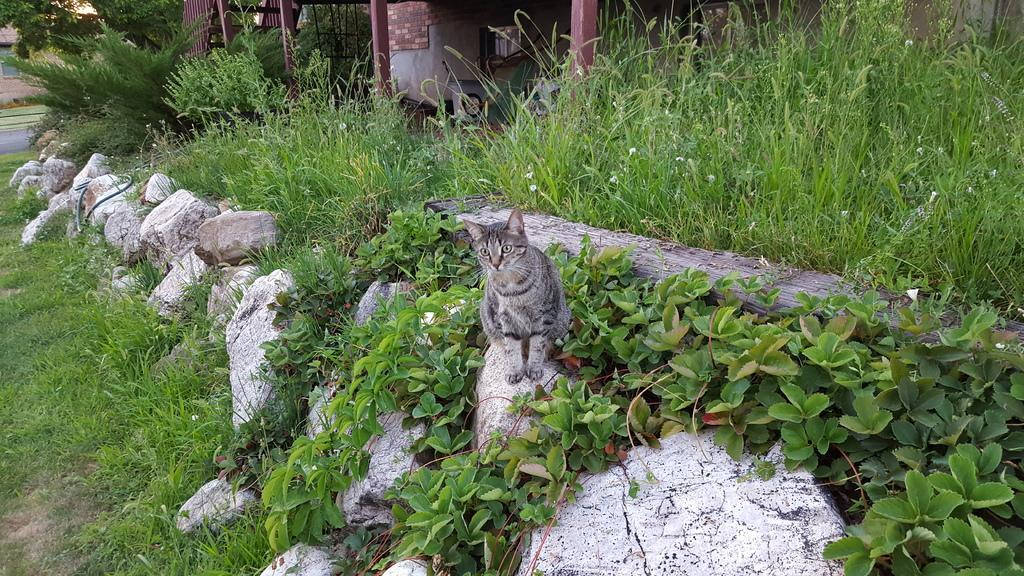What animal is present in the image? There is a cat in the image. What is the cat standing on? The cat is standing on a stone. Can you describe the coloring of the cat? The cat has brown and black coloring. What can be seen in the background of the image? There are trees in the background of the image. What is the color of the trees in the image? The trees are green in color. What type of stew is being prepared in the image? There is no stew present in the image; it features a cat standing on a stone with trees in the background. What territory is the cat claiming in the image? The image does not depict the cat claiming any territory; it simply shows the cat standing on a stone. 